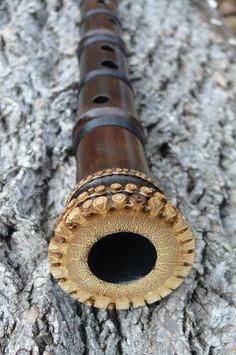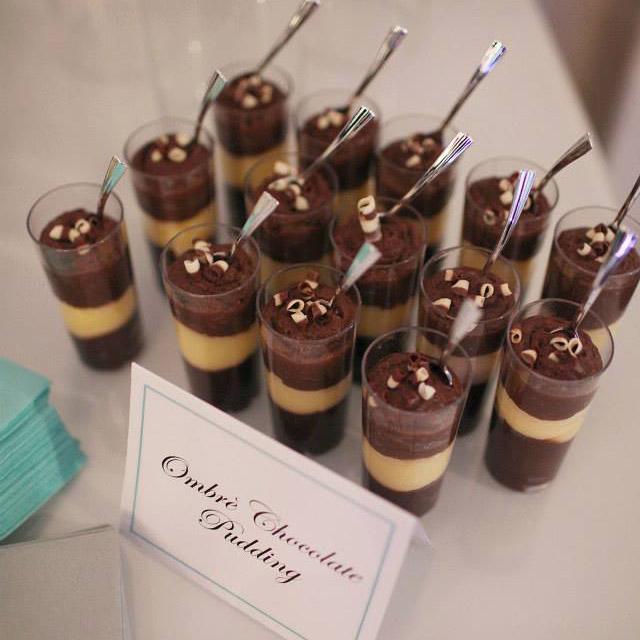The first image is the image on the left, the second image is the image on the right. Examine the images to the left and right. Is the description "there is a dark satined wood flute on a wooden table with a multicolored leaf on it" accurate? Answer yes or no. No. 